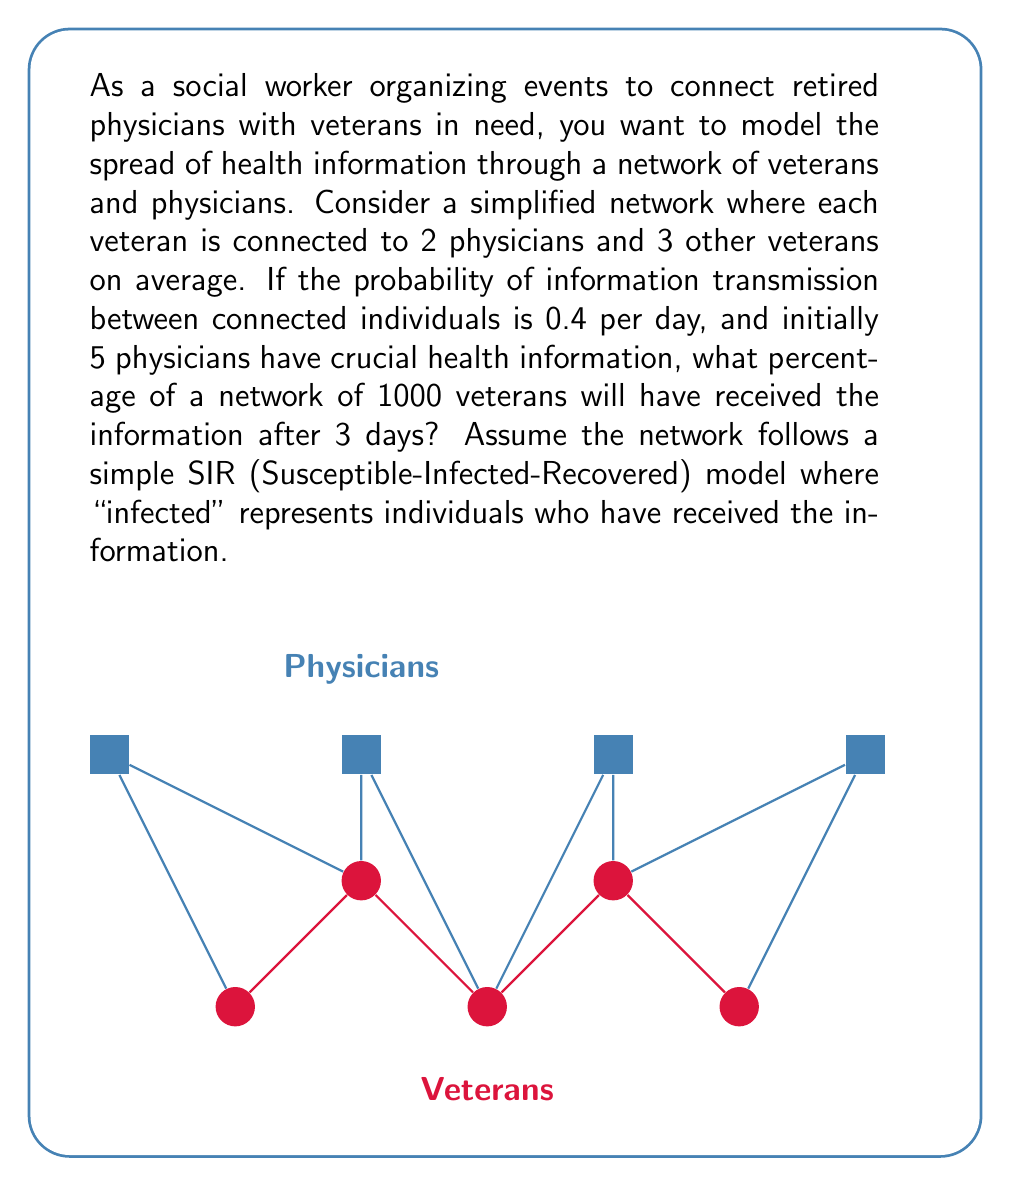Show me your answer to this math problem. Let's approach this step-by-step using the SIR model:

1) First, we need to calculate the total number of connections in the network:
   - Each veteran has 2 physician connections and 3 veteran connections
   - Total connections per veteran = 2 + 3 = 5
   - Total connections in the network = 1000 * 5 / 2 = 2500 (divided by 2 to avoid double-counting)

2) The rate of information spread per day can be calculated as:
   $\beta = 0.4 * 5 = 2$ (probability of transmission * average connections)

3) We can use the differential equation for the SIR model:
   $$\frac{dI}{dt} = \beta SI - \gamma I$$
   Where $S$ is the proportion of susceptible individuals, $I$ is the proportion of infected (informed), and $\gamma$ is the recovery rate (which we can ignore in this case as we're only interested in information spread).

4) Simplifying for our case:
   $$\frac{dI}{dt} = 2I(1-I)$$

5) The solution to this differential equation is:
   $$I(t) = \frac{I_0 e^{2t}}{1 + I_0(e^{2t} - 1)}$$
   Where $I_0$ is the initial proportion of informed individuals.

6) Initially, 5 physicians have the information:
   $I_0 = \frac{5}{1000 + 5} \approx 0.00498$

7) After 3 days:
   $$I(3) = \frac{0.00498 e^{2*3}}{1 + 0.00498(e^{2*3} - 1)} \approx 0.7716$$

8) Convert to percentage:
   0.7716 * 100 ≈ 77.16%

Therefore, after 3 days, approximately 77.16% of the network will have received the information.
Answer: 77.16% 